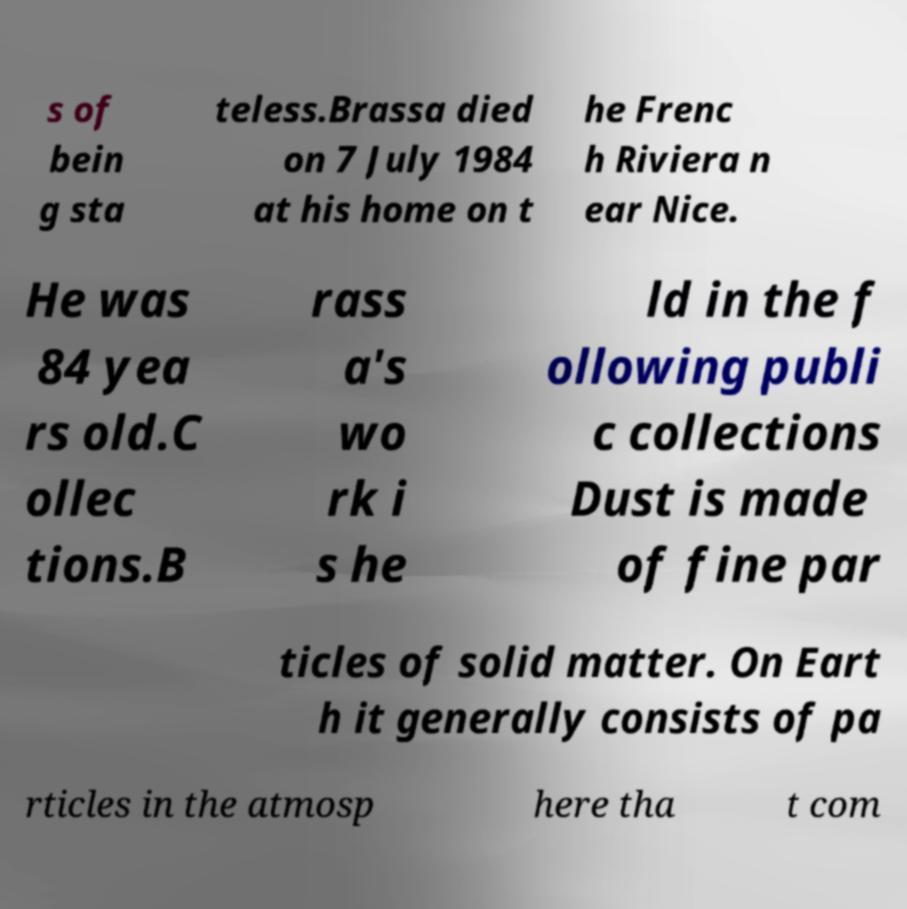Can you read and provide the text displayed in the image?This photo seems to have some interesting text. Can you extract and type it out for me? s of bein g sta teless.Brassa died on 7 July 1984 at his home on t he Frenc h Riviera n ear Nice. He was 84 yea rs old.C ollec tions.B rass a's wo rk i s he ld in the f ollowing publi c collections Dust is made of fine par ticles of solid matter. On Eart h it generally consists of pa rticles in the atmosp here tha t com 